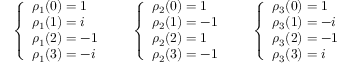Convert formula to latex. <formula><loc_0><loc_0><loc_500><loc_500>{ \left \{ \begin{array} { l l } { \rho _ { 1 } ( { 0 } ) = 1 } \\ { \rho _ { 1 } ( { 1 } ) = i } \\ { \rho _ { 1 } ( { 2 } ) = - 1 } \\ { \rho _ { 1 } ( { 3 } ) = - i } \end{array} } \quad { \left \{ \begin{array} { l l } { \rho _ { 2 } ( { 0 } ) = 1 } \\ { \rho _ { 2 } ( { 1 } ) = - 1 } \\ { \rho _ { 2 } ( { 2 } ) = 1 } \\ { \rho _ { 2 } ( { 3 } ) = - 1 } \end{array} } \quad { \left \{ \begin{array} { l l } { \rho _ { 3 } ( { 0 } ) = 1 } \\ { \rho _ { 3 } ( { 1 } ) = - i } \\ { \rho _ { 3 } ( { 2 } ) = - 1 } \\ { \rho _ { 3 } ( { 3 } ) = i } \end{array} }</formula> 